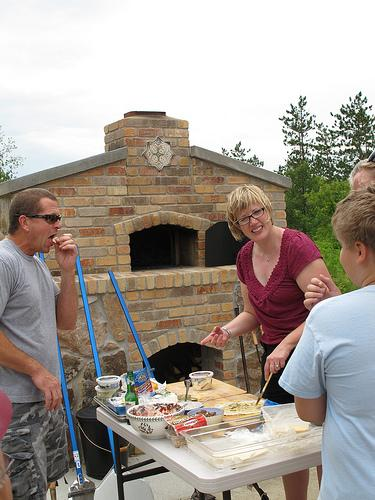How many cutting boards are in the image and what are they made of? There are two wooden cutting boards in the image. Identify the primary activity happening in the image and describe the people involved. The woman is preparing a pizza, with a man and a boy nearby wearing a gray shirt and a blue shirt respectively, and the man is about to take a bite. List the clothing items worn by the man and describe their colors. The man is wearing sunglasses, a short sleeve grey shirt, grey and black camouflage shorts, and grey cargo pants. Provide a detailed description of the woman's appearance in the image. The woman has short blonde hair, is wearing glasses, a burgundy shirt, and a wedding ring, and is holding a brush. Mention the number of trees in the image and describe their color. There are two green pine trees and a cluster of green trees in the image. What is the main object in the image and its additional features? The main object is a pizza oven made from bricks, which is located outdoors near trees. Explain the type of oven featured in the image and its positioning. An outdoor brick oven is in the image's background acting as a focal point and it is adjacent to a stone pit with a marking. Identify the types and colors of the shirts worn by the woman, the man, and the boy in the image. The woman is wearing a short sleeve purple shirt, the man is wearing a short sleeve white tee shirt, and the boy is wearing a light blue shirt. Describe the various tools and items present in the vicinity of the people. Three blue garden tools, a peel, a small gray and yellow tub, and blue handle of broom are present nearby the people. What food items are present on the table and describe the appearance of the table. There is a table full of food items, including a bowl of fresh fruit, and the table has a white edge and a black leg. What distinctive piece of clothing is the man in the image wearing? The man is wearing grey and black camouflage shorts. Describe the location of the event and the elements present in a poetic way. In a lush green haven, amidst verdant trees and warm bricks, they create culinary arts as love and dough blend into transcendent pizzas. Describe the man and woman's outfits in a casual and colloquial style. Dude's rockin' a grey shirt, camo shorts, and shades. Chick's got a burgundy shirt, glasses, and a wedding ring. Describe the object at the position (86, 301) in detail. It is a peel, used for handling pizzas in and out of the oven. Can you spot any trees in the image? If so, how many green pine trees do you see? Yes, there are two green pine trees. Are there four blue garden tools on the table? The instruction is misleading because there are only three blue garden tools mentioned in the given information. This suggests that there is an additional garden tool that is not actually present. Can you infer if the woman is married based on the image? Yes, the woman is wearing a wedding ring. Is there an ongoing event happening in the image? If yes, what is it? Yes, a couple is preparing a pizza outdoors. Describe the shirt worn by the woman in the picture. The woman is wearing a short sleeve purple shirt. Are there any blue-colored objects present in the image? If so, what are they? Yes, there are three blue garden tools and blue broom handles. What material is used for constructing the object at the position (91, 153)? bricks Is the woman's eyeglasses orange? The instruction is misleading because the woman's eyeglasses are not described as being orange. This suggests that her eyeglasses have a specific color, which is not mentioned in the given information. Given the presence of the pizza oven and cooking utensils, what type of meal is likely being prepared? A pizza meal is being prepared. Multiple choice question: Which accessory is the woman wearing? b) Glasses Are there any words or text visible in the image? No words or text are visible. What are the colors of the shirts worn by the man and the woman in the image? The man is wearing a grey shirt, and the woman is wearing a burgundy shirt. Is the pizza oven in the foreground made of metal? The instruction is misleading because the pizza oven is made from bricks and not metal. It suggests that the oven is made of a different material than described in the given information. Is the man wearing a red shirt? The instruction is misleading because the man is actually wearing a grey shirt. It suggests that the man is wearing a red shirt, which is not accurate. Identify the action being performed by the woman in the scene. The woman is preparing a pizza. Explain the overall layout of the scene shown in the image. In an outdoor setting, there is a brick pizza oven, a table full of food and ingredients, a woman preparing a pizza, and a man wearing sunglasses. Based on the image, what do you think is the primary purpose of the gathering? The primary purpose of the gathering is to prepare and cook pizzas outdoors with friends. Is the woman wearing a bright yellow shirt? The instruction is misleading because the woman is actually wearing a burgundy shirt, not a yellow one. It implies that she is wearing a different colored shirt than what is described in the information. Are the trees in the background pink? The instruction is misleading because the trees are green, not pink. It implies that there are pink trees in the background, which is incorrect. What object can you find at the position with left-top corner coordinates (9, 120)? a pizza oven 